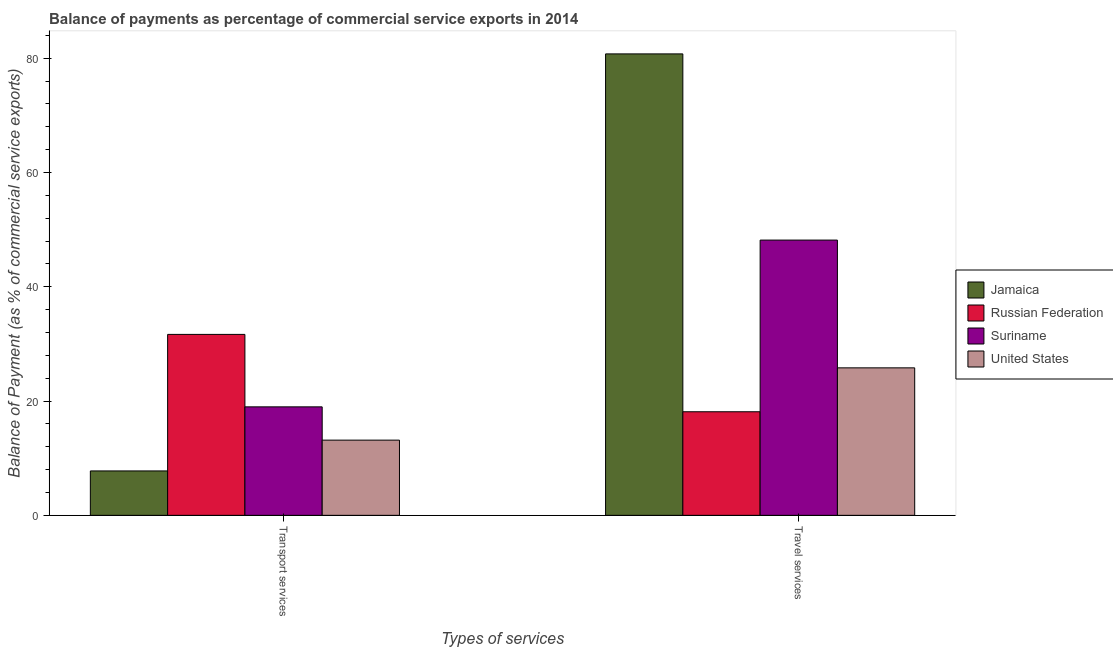How many different coloured bars are there?
Your answer should be very brief. 4. How many bars are there on the 2nd tick from the right?
Your response must be concise. 4. What is the label of the 2nd group of bars from the left?
Offer a terse response. Travel services. What is the balance of payments of transport services in Russian Federation?
Provide a short and direct response. 31.67. Across all countries, what is the maximum balance of payments of travel services?
Provide a short and direct response. 80.75. Across all countries, what is the minimum balance of payments of travel services?
Provide a short and direct response. 18.13. In which country was the balance of payments of transport services maximum?
Your response must be concise. Russian Federation. In which country was the balance of payments of transport services minimum?
Provide a short and direct response. Jamaica. What is the total balance of payments of transport services in the graph?
Provide a succinct answer. 71.59. What is the difference between the balance of payments of transport services in Jamaica and that in United States?
Ensure brevity in your answer.  -5.39. What is the difference between the balance of payments of travel services in Russian Federation and the balance of payments of transport services in Suriname?
Give a very brief answer. -0.86. What is the average balance of payments of transport services per country?
Keep it short and to the point. 17.9. What is the difference between the balance of payments of transport services and balance of payments of travel services in Suriname?
Your answer should be compact. -29.18. What is the ratio of the balance of payments of transport services in Suriname to that in Russian Federation?
Your answer should be very brief. 0.6. What does the 1st bar from the left in Transport services represents?
Make the answer very short. Jamaica. What does the 4th bar from the right in Travel services represents?
Your answer should be compact. Jamaica. What is the difference between two consecutive major ticks on the Y-axis?
Your answer should be very brief. 20. Are the values on the major ticks of Y-axis written in scientific E-notation?
Give a very brief answer. No. Does the graph contain any zero values?
Your response must be concise. No. Where does the legend appear in the graph?
Ensure brevity in your answer.  Center right. How many legend labels are there?
Your answer should be very brief. 4. What is the title of the graph?
Provide a short and direct response. Balance of payments as percentage of commercial service exports in 2014. Does "Seychelles" appear as one of the legend labels in the graph?
Keep it short and to the point. No. What is the label or title of the X-axis?
Provide a succinct answer. Types of services. What is the label or title of the Y-axis?
Provide a short and direct response. Balance of Payment (as % of commercial service exports). What is the Balance of Payment (as % of commercial service exports) of Jamaica in Transport services?
Ensure brevity in your answer.  7.77. What is the Balance of Payment (as % of commercial service exports) of Russian Federation in Transport services?
Your response must be concise. 31.67. What is the Balance of Payment (as % of commercial service exports) of Suriname in Transport services?
Keep it short and to the point. 18.99. What is the Balance of Payment (as % of commercial service exports) of United States in Transport services?
Offer a very short reply. 13.16. What is the Balance of Payment (as % of commercial service exports) in Jamaica in Travel services?
Provide a succinct answer. 80.75. What is the Balance of Payment (as % of commercial service exports) in Russian Federation in Travel services?
Offer a very short reply. 18.13. What is the Balance of Payment (as % of commercial service exports) of Suriname in Travel services?
Your answer should be very brief. 48.17. What is the Balance of Payment (as % of commercial service exports) in United States in Travel services?
Provide a short and direct response. 25.81. Across all Types of services, what is the maximum Balance of Payment (as % of commercial service exports) in Jamaica?
Your answer should be very brief. 80.75. Across all Types of services, what is the maximum Balance of Payment (as % of commercial service exports) in Russian Federation?
Your response must be concise. 31.67. Across all Types of services, what is the maximum Balance of Payment (as % of commercial service exports) of Suriname?
Make the answer very short. 48.17. Across all Types of services, what is the maximum Balance of Payment (as % of commercial service exports) of United States?
Keep it short and to the point. 25.81. Across all Types of services, what is the minimum Balance of Payment (as % of commercial service exports) in Jamaica?
Give a very brief answer. 7.77. Across all Types of services, what is the minimum Balance of Payment (as % of commercial service exports) of Russian Federation?
Your response must be concise. 18.13. Across all Types of services, what is the minimum Balance of Payment (as % of commercial service exports) of Suriname?
Make the answer very short. 18.99. Across all Types of services, what is the minimum Balance of Payment (as % of commercial service exports) in United States?
Provide a succinct answer. 13.16. What is the total Balance of Payment (as % of commercial service exports) of Jamaica in the graph?
Make the answer very short. 88.53. What is the total Balance of Payment (as % of commercial service exports) in Russian Federation in the graph?
Your answer should be very brief. 49.79. What is the total Balance of Payment (as % of commercial service exports) in Suriname in the graph?
Keep it short and to the point. 67.15. What is the total Balance of Payment (as % of commercial service exports) of United States in the graph?
Make the answer very short. 38.97. What is the difference between the Balance of Payment (as % of commercial service exports) of Jamaica in Transport services and that in Travel services?
Offer a terse response. -72.98. What is the difference between the Balance of Payment (as % of commercial service exports) of Russian Federation in Transport services and that in Travel services?
Offer a very short reply. 13.54. What is the difference between the Balance of Payment (as % of commercial service exports) of Suriname in Transport services and that in Travel services?
Offer a very short reply. -29.18. What is the difference between the Balance of Payment (as % of commercial service exports) of United States in Transport services and that in Travel services?
Ensure brevity in your answer.  -12.65. What is the difference between the Balance of Payment (as % of commercial service exports) of Jamaica in Transport services and the Balance of Payment (as % of commercial service exports) of Russian Federation in Travel services?
Give a very brief answer. -10.35. What is the difference between the Balance of Payment (as % of commercial service exports) of Jamaica in Transport services and the Balance of Payment (as % of commercial service exports) of Suriname in Travel services?
Give a very brief answer. -40.4. What is the difference between the Balance of Payment (as % of commercial service exports) in Jamaica in Transport services and the Balance of Payment (as % of commercial service exports) in United States in Travel services?
Your answer should be compact. -18.04. What is the difference between the Balance of Payment (as % of commercial service exports) of Russian Federation in Transport services and the Balance of Payment (as % of commercial service exports) of Suriname in Travel services?
Offer a terse response. -16.5. What is the difference between the Balance of Payment (as % of commercial service exports) of Russian Federation in Transport services and the Balance of Payment (as % of commercial service exports) of United States in Travel services?
Your response must be concise. 5.85. What is the difference between the Balance of Payment (as % of commercial service exports) in Suriname in Transport services and the Balance of Payment (as % of commercial service exports) in United States in Travel services?
Give a very brief answer. -6.83. What is the average Balance of Payment (as % of commercial service exports) of Jamaica per Types of services?
Provide a succinct answer. 44.26. What is the average Balance of Payment (as % of commercial service exports) in Russian Federation per Types of services?
Keep it short and to the point. 24.9. What is the average Balance of Payment (as % of commercial service exports) of Suriname per Types of services?
Make the answer very short. 33.58. What is the average Balance of Payment (as % of commercial service exports) in United States per Types of services?
Your answer should be very brief. 19.49. What is the difference between the Balance of Payment (as % of commercial service exports) of Jamaica and Balance of Payment (as % of commercial service exports) of Russian Federation in Transport services?
Your response must be concise. -23.89. What is the difference between the Balance of Payment (as % of commercial service exports) of Jamaica and Balance of Payment (as % of commercial service exports) of Suriname in Transport services?
Give a very brief answer. -11.21. What is the difference between the Balance of Payment (as % of commercial service exports) of Jamaica and Balance of Payment (as % of commercial service exports) of United States in Transport services?
Make the answer very short. -5.39. What is the difference between the Balance of Payment (as % of commercial service exports) of Russian Federation and Balance of Payment (as % of commercial service exports) of Suriname in Transport services?
Keep it short and to the point. 12.68. What is the difference between the Balance of Payment (as % of commercial service exports) in Russian Federation and Balance of Payment (as % of commercial service exports) in United States in Transport services?
Offer a very short reply. 18.5. What is the difference between the Balance of Payment (as % of commercial service exports) of Suriname and Balance of Payment (as % of commercial service exports) of United States in Transport services?
Offer a very short reply. 5.82. What is the difference between the Balance of Payment (as % of commercial service exports) in Jamaica and Balance of Payment (as % of commercial service exports) in Russian Federation in Travel services?
Keep it short and to the point. 62.63. What is the difference between the Balance of Payment (as % of commercial service exports) in Jamaica and Balance of Payment (as % of commercial service exports) in Suriname in Travel services?
Your answer should be compact. 32.58. What is the difference between the Balance of Payment (as % of commercial service exports) of Jamaica and Balance of Payment (as % of commercial service exports) of United States in Travel services?
Give a very brief answer. 54.94. What is the difference between the Balance of Payment (as % of commercial service exports) in Russian Federation and Balance of Payment (as % of commercial service exports) in Suriname in Travel services?
Offer a terse response. -30.04. What is the difference between the Balance of Payment (as % of commercial service exports) of Russian Federation and Balance of Payment (as % of commercial service exports) of United States in Travel services?
Provide a short and direct response. -7.68. What is the difference between the Balance of Payment (as % of commercial service exports) in Suriname and Balance of Payment (as % of commercial service exports) in United States in Travel services?
Ensure brevity in your answer.  22.36. What is the ratio of the Balance of Payment (as % of commercial service exports) in Jamaica in Transport services to that in Travel services?
Your answer should be very brief. 0.1. What is the ratio of the Balance of Payment (as % of commercial service exports) in Russian Federation in Transport services to that in Travel services?
Offer a terse response. 1.75. What is the ratio of the Balance of Payment (as % of commercial service exports) in Suriname in Transport services to that in Travel services?
Give a very brief answer. 0.39. What is the ratio of the Balance of Payment (as % of commercial service exports) in United States in Transport services to that in Travel services?
Make the answer very short. 0.51. What is the difference between the highest and the second highest Balance of Payment (as % of commercial service exports) in Jamaica?
Offer a terse response. 72.98. What is the difference between the highest and the second highest Balance of Payment (as % of commercial service exports) in Russian Federation?
Your answer should be compact. 13.54. What is the difference between the highest and the second highest Balance of Payment (as % of commercial service exports) of Suriname?
Your response must be concise. 29.18. What is the difference between the highest and the second highest Balance of Payment (as % of commercial service exports) in United States?
Offer a very short reply. 12.65. What is the difference between the highest and the lowest Balance of Payment (as % of commercial service exports) of Jamaica?
Your response must be concise. 72.98. What is the difference between the highest and the lowest Balance of Payment (as % of commercial service exports) in Russian Federation?
Offer a very short reply. 13.54. What is the difference between the highest and the lowest Balance of Payment (as % of commercial service exports) in Suriname?
Your answer should be compact. 29.18. What is the difference between the highest and the lowest Balance of Payment (as % of commercial service exports) of United States?
Keep it short and to the point. 12.65. 